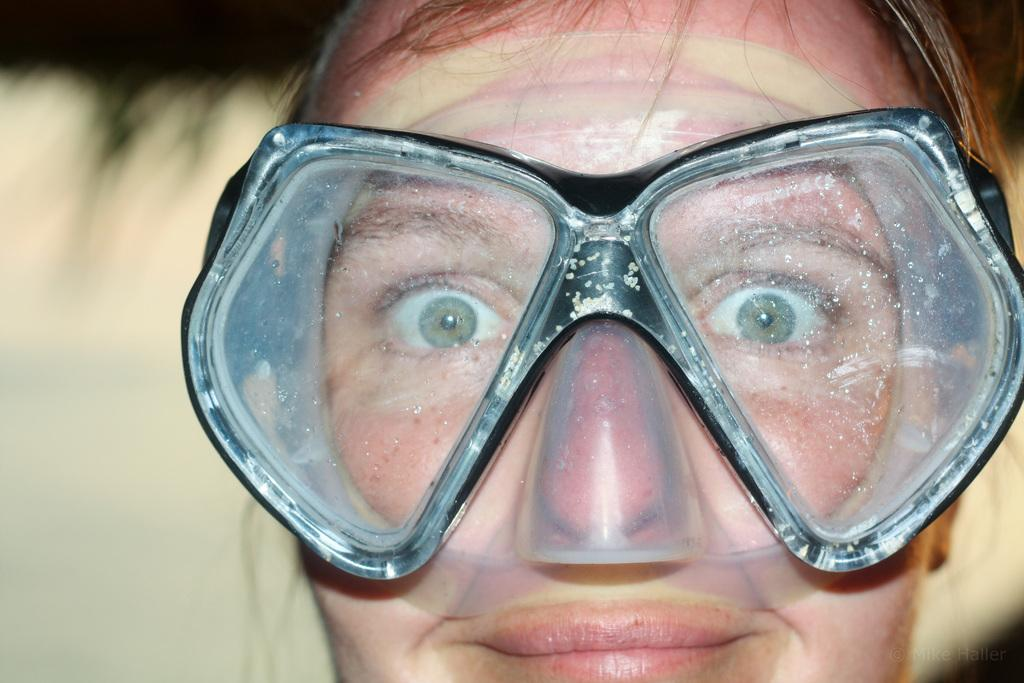Who is present in the image? There is a person in the image. What is the person wearing on their face? The person is wearing a mask to the face. What songs are being sung by the person in the image? There is no indication in the image that the person is singing any songs. 